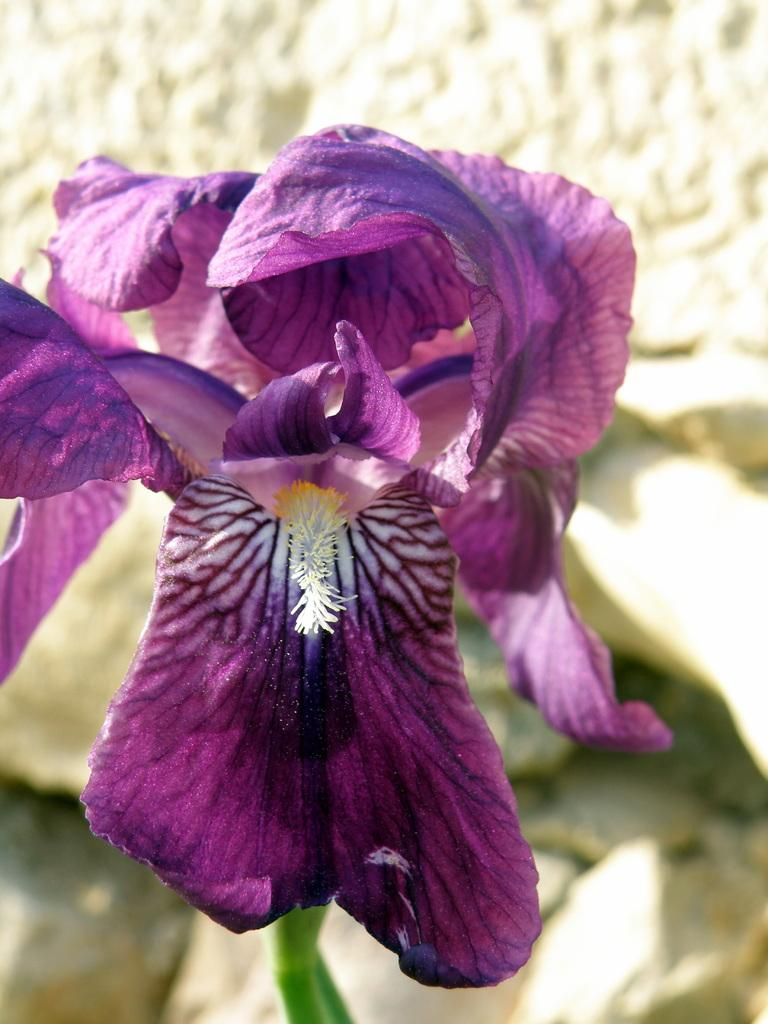What type of flower is in the picture? There is a violet flower in the picture. Can you describe the flower's structure? The flower has petals and a stem. What can be seen in the background of the image? The backdrop of the image is blurred. What type of glue is being used to hold the business card in the image? There is no business card or glue present in the image; it features a violet flower with petals and a stem against a blurred backdrop. What type of cloud can be seen in the image? There is no cloud present in the image; it features a violet flower with petals and a stem against a blurred backdrop. 